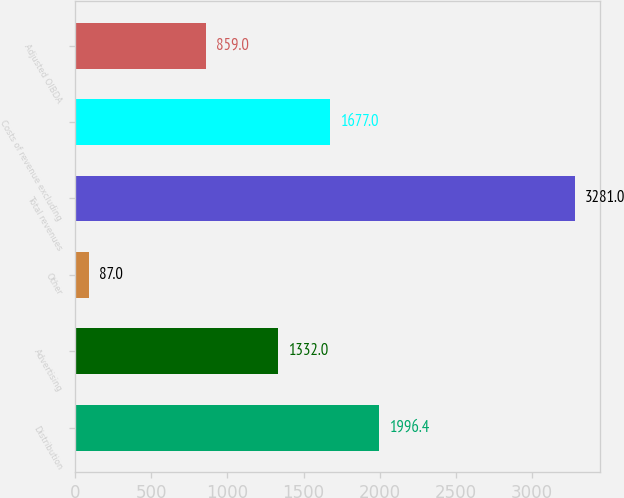Convert chart to OTSL. <chart><loc_0><loc_0><loc_500><loc_500><bar_chart><fcel>Distribution<fcel>Advertising<fcel>Other<fcel>Total revenues<fcel>Costs of revenue excluding<fcel>Adjusted OIBDA<nl><fcel>1996.4<fcel>1332<fcel>87<fcel>3281<fcel>1677<fcel>859<nl></chart> 